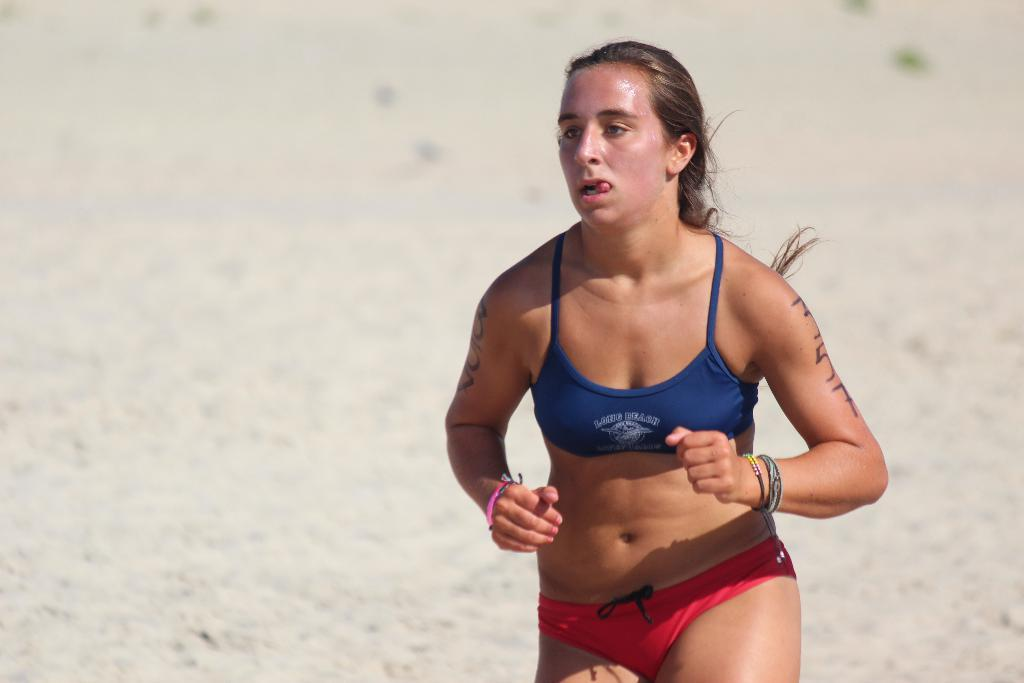Who is the main subject in the image? There is a woman in the image. What is the woman doing in the image? The woman is running. What can be seen in the background of the image? There is a ground in the background of the image. What type of disease is the woman suffering from in the image? There is no indication of any disease in the image; the woman is simply running. 